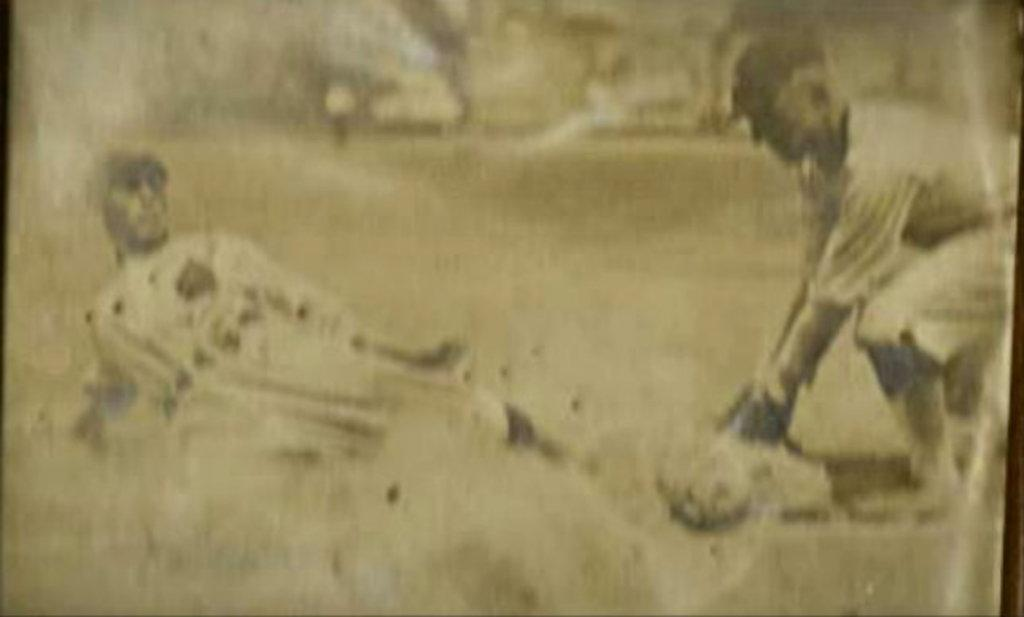How many people are present in the image? There are two people in the image. What are the people wearing? Both people are wearing white color dresses. Can you describe the quality of the image? The image is blurred. Are the two people in the image sisters? There is no information in the image to suggest that the two people are sisters. Can you see a patch on one of the dresses in the image? There is no patch visible on either of the dresses in the image. 